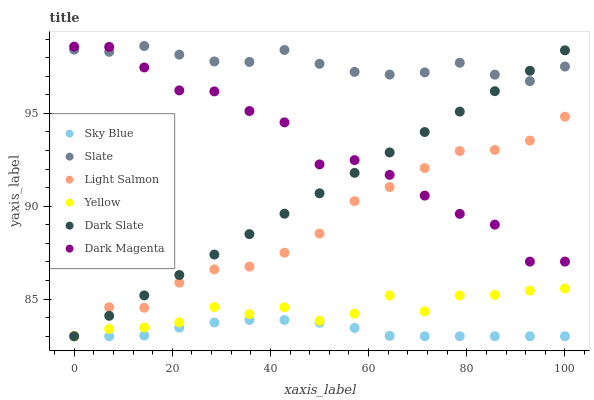Does Sky Blue have the minimum area under the curve?
Answer yes or no. Yes. Does Slate have the maximum area under the curve?
Answer yes or no. Yes. Does Dark Magenta have the minimum area under the curve?
Answer yes or no. No. Does Dark Magenta have the maximum area under the curve?
Answer yes or no. No. Is Dark Slate the smoothest?
Answer yes or no. Yes. Is Dark Magenta the roughest?
Answer yes or no. Yes. Is Slate the smoothest?
Answer yes or no. No. Is Slate the roughest?
Answer yes or no. No. Does Light Salmon have the lowest value?
Answer yes or no. Yes. Does Dark Magenta have the lowest value?
Answer yes or no. No. Does Slate have the highest value?
Answer yes or no. Yes. Does Dark Magenta have the highest value?
Answer yes or no. No. Is Yellow less than Dark Magenta?
Answer yes or no. Yes. Is Slate greater than Yellow?
Answer yes or no. Yes. Does Light Salmon intersect Dark Magenta?
Answer yes or no. Yes. Is Light Salmon less than Dark Magenta?
Answer yes or no. No. Is Light Salmon greater than Dark Magenta?
Answer yes or no. No. Does Yellow intersect Dark Magenta?
Answer yes or no. No. 